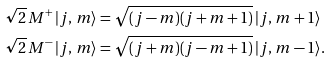Convert formula to latex. <formula><loc_0><loc_0><loc_500><loc_500>\sqrt { 2 } \, M ^ { + } \, | j , \, m \rangle & = \sqrt { ( j - m ) ( j + m + 1 ) } \, | j , \, m + 1 \rangle \\ \sqrt { 2 } \, M ^ { - } \, | j , \, m \rangle & = \sqrt { ( j + m ) ( j - m + 1 ) } \, | j , \, m - 1 \rangle .</formula> 